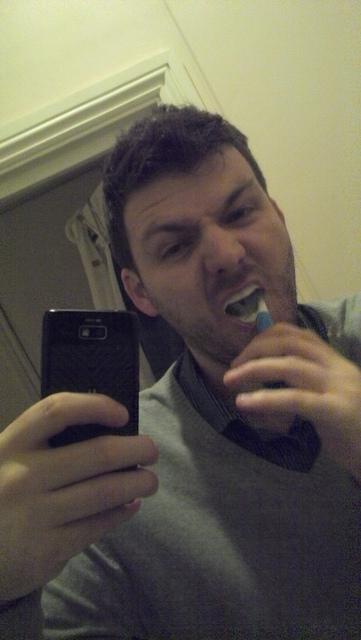Is this person happy?
Answer briefly. No. What was this man probably doing before he fell asleep?
Answer briefly. Brushing teeth. Is this man trying to be funny?
Keep it brief. Yes. Is a human shown?
Give a very brief answer. Yes. What kind of phone is this person holding?
Keep it brief. Android. Where is the man?
Concise answer only. Bathroom. What is the man eating?
Answer briefly. Nothing. What flavor is the toothpaste likely to be?
Keep it brief. Mint. What game system is he playing?
Keep it brief. Phone. Is he brushing?
Quick response, please. Yes. What is in the man's hand?
Short answer required. Phone. What color is the wall?
Quick response, please. White. Is someone a gamer?
Give a very brief answer. No. What is the person holding?
Short answer required. Phone. What color is the giraffe's tongue?
Quick response, please. Black. Is this a man or a woman?
Quick response, please. Man. Was the photographer leaning right?
Concise answer only. Yes. Is that a man or a woman?
Answer briefly. Man. What is that white thing in his hands?
Short answer required. Toothbrush. Is he wearing a hat?
Be succinct. No. What color is his shirt?
Short answer required. Gray. Who created this art piece?
Be succinct. Man. How many toothbrushes?
Short answer required. 1. Does the person have a ring on?
Short answer required. No. What color is the man's necktie?
Write a very short answer. Black. How many shirts does this man have on?
Concise answer only. 2. What is the man holding to his neck?
Short answer required. Toothbrush. Is this photoshopped?
Give a very brief answer. No. What is the reflection of?
Concise answer only. Man. What is this person holding?
Write a very short answer. Phone. What is the level the man is holding with his thumb called?
Be succinct. Unknown. What is behind the man?
Quick response, please. Doorway. 